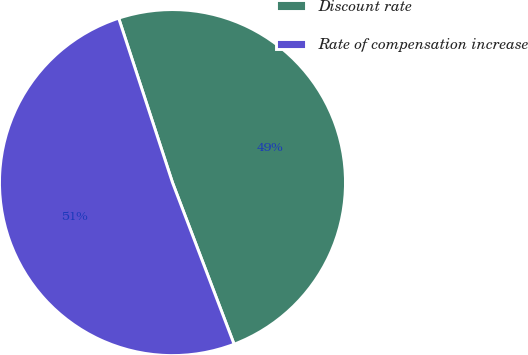Convert chart to OTSL. <chart><loc_0><loc_0><loc_500><loc_500><pie_chart><fcel>Discount rate<fcel>Rate of compensation increase<nl><fcel>49.24%<fcel>50.76%<nl></chart> 